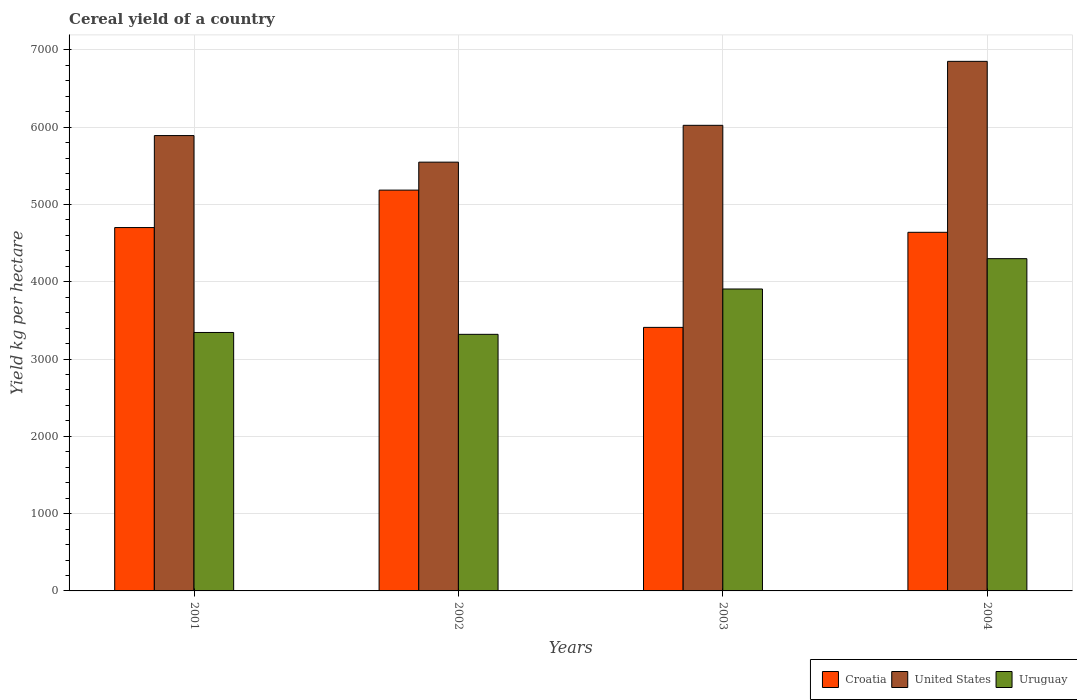How many different coloured bars are there?
Your response must be concise. 3. How many groups of bars are there?
Your answer should be compact. 4. How many bars are there on the 3rd tick from the right?
Keep it short and to the point. 3. What is the label of the 3rd group of bars from the left?
Make the answer very short. 2003. In how many cases, is the number of bars for a given year not equal to the number of legend labels?
Keep it short and to the point. 0. What is the total cereal yield in United States in 2004?
Make the answer very short. 6851.66. Across all years, what is the maximum total cereal yield in United States?
Your answer should be very brief. 6851.66. Across all years, what is the minimum total cereal yield in Croatia?
Provide a succinct answer. 3409.78. What is the total total cereal yield in Uruguay in the graph?
Give a very brief answer. 1.49e+04. What is the difference between the total cereal yield in Croatia in 2002 and that in 2003?
Your answer should be very brief. 1775.9. What is the difference between the total cereal yield in Croatia in 2001 and the total cereal yield in Uruguay in 2004?
Keep it short and to the point. 402.5. What is the average total cereal yield in United States per year?
Provide a succinct answer. 6078.67. In the year 2001, what is the difference between the total cereal yield in Croatia and total cereal yield in United States?
Offer a terse response. -1190.12. In how many years, is the total cereal yield in United States greater than 4200 kg per hectare?
Keep it short and to the point. 4. What is the ratio of the total cereal yield in United States in 2001 to that in 2003?
Provide a succinct answer. 0.98. What is the difference between the highest and the second highest total cereal yield in Uruguay?
Make the answer very short. 392.42. What is the difference between the highest and the lowest total cereal yield in United States?
Offer a terse response. 1304.18. In how many years, is the total cereal yield in Uruguay greater than the average total cereal yield in Uruguay taken over all years?
Your response must be concise. 2. Is the sum of the total cereal yield in Uruguay in 2001 and 2002 greater than the maximum total cereal yield in Croatia across all years?
Provide a short and direct response. Yes. What does the 1st bar from the left in 2003 represents?
Offer a terse response. Croatia. What does the 1st bar from the right in 2004 represents?
Your answer should be compact. Uruguay. Is it the case that in every year, the sum of the total cereal yield in Uruguay and total cereal yield in United States is greater than the total cereal yield in Croatia?
Ensure brevity in your answer.  Yes. How many bars are there?
Offer a very short reply. 12. Are all the bars in the graph horizontal?
Your answer should be very brief. No. What is the difference between two consecutive major ticks on the Y-axis?
Offer a terse response. 1000. Are the values on the major ticks of Y-axis written in scientific E-notation?
Keep it short and to the point. No. Where does the legend appear in the graph?
Offer a very short reply. Bottom right. What is the title of the graph?
Offer a very short reply. Cereal yield of a country. Does "Greenland" appear as one of the legend labels in the graph?
Keep it short and to the point. No. What is the label or title of the Y-axis?
Offer a very short reply. Yield kg per hectare. What is the Yield kg per hectare in Croatia in 2001?
Keep it short and to the point. 4701.4. What is the Yield kg per hectare in United States in 2001?
Your answer should be compact. 5891.52. What is the Yield kg per hectare in Uruguay in 2001?
Your answer should be compact. 3343.86. What is the Yield kg per hectare of Croatia in 2002?
Keep it short and to the point. 5185.67. What is the Yield kg per hectare in United States in 2002?
Provide a short and direct response. 5547.48. What is the Yield kg per hectare in Uruguay in 2002?
Your answer should be compact. 3319.71. What is the Yield kg per hectare in Croatia in 2003?
Keep it short and to the point. 3409.78. What is the Yield kg per hectare in United States in 2003?
Your response must be concise. 6024.03. What is the Yield kg per hectare of Uruguay in 2003?
Keep it short and to the point. 3906.49. What is the Yield kg per hectare in Croatia in 2004?
Provide a short and direct response. 4639.93. What is the Yield kg per hectare of United States in 2004?
Your answer should be compact. 6851.66. What is the Yield kg per hectare in Uruguay in 2004?
Your answer should be compact. 4298.91. Across all years, what is the maximum Yield kg per hectare in Croatia?
Your answer should be very brief. 5185.67. Across all years, what is the maximum Yield kg per hectare of United States?
Ensure brevity in your answer.  6851.66. Across all years, what is the maximum Yield kg per hectare of Uruguay?
Provide a succinct answer. 4298.91. Across all years, what is the minimum Yield kg per hectare of Croatia?
Provide a short and direct response. 3409.78. Across all years, what is the minimum Yield kg per hectare of United States?
Offer a very short reply. 5547.48. Across all years, what is the minimum Yield kg per hectare in Uruguay?
Give a very brief answer. 3319.71. What is the total Yield kg per hectare of Croatia in the graph?
Give a very brief answer. 1.79e+04. What is the total Yield kg per hectare of United States in the graph?
Give a very brief answer. 2.43e+04. What is the total Yield kg per hectare of Uruguay in the graph?
Offer a terse response. 1.49e+04. What is the difference between the Yield kg per hectare in Croatia in 2001 and that in 2002?
Provide a short and direct response. -484.27. What is the difference between the Yield kg per hectare in United States in 2001 and that in 2002?
Ensure brevity in your answer.  344.05. What is the difference between the Yield kg per hectare in Uruguay in 2001 and that in 2002?
Provide a short and direct response. 24.16. What is the difference between the Yield kg per hectare of Croatia in 2001 and that in 2003?
Provide a short and direct response. 1291.63. What is the difference between the Yield kg per hectare in United States in 2001 and that in 2003?
Keep it short and to the point. -132.51. What is the difference between the Yield kg per hectare of Uruguay in 2001 and that in 2003?
Your response must be concise. -562.62. What is the difference between the Yield kg per hectare of Croatia in 2001 and that in 2004?
Keep it short and to the point. 61.48. What is the difference between the Yield kg per hectare in United States in 2001 and that in 2004?
Ensure brevity in your answer.  -960.14. What is the difference between the Yield kg per hectare in Uruguay in 2001 and that in 2004?
Offer a very short reply. -955.04. What is the difference between the Yield kg per hectare of Croatia in 2002 and that in 2003?
Your answer should be compact. 1775.9. What is the difference between the Yield kg per hectare of United States in 2002 and that in 2003?
Give a very brief answer. -476.56. What is the difference between the Yield kg per hectare of Uruguay in 2002 and that in 2003?
Keep it short and to the point. -586.78. What is the difference between the Yield kg per hectare in Croatia in 2002 and that in 2004?
Make the answer very short. 545.75. What is the difference between the Yield kg per hectare of United States in 2002 and that in 2004?
Your answer should be very brief. -1304.18. What is the difference between the Yield kg per hectare in Uruguay in 2002 and that in 2004?
Offer a very short reply. -979.2. What is the difference between the Yield kg per hectare in Croatia in 2003 and that in 2004?
Your answer should be very brief. -1230.15. What is the difference between the Yield kg per hectare of United States in 2003 and that in 2004?
Your answer should be compact. -827.63. What is the difference between the Yield kg per hectare of Uruguay in 2003 and that in 2004?
Your answer should be compact. -392.42. What is the difference between the Yield kg per hectare in Croatia in 2001 and the Yield kg per hectare in United States in 2002?
Ensure brevity in your answer.  -846.07. What is the difference between the Yield kg per hectare of Croatia in 2001 and the Yield kg per hectare of Uruguay in 2002?
Provide a short and direct response. 1381.69. What is the difference between the Yield kg per hectare in United States in 2001 and the Yield kg per hectare in Uruguay in 2002?
Your response must be concise. 2571.81. What is the difference between the Yield kg per hectare of Croatia in 2001 and the Yield kg per hectare of United States in 2003?
Provide a succinct answer. -1322.63. What is the difference between the Yield kg per hectare of Croatia in 2001 and the Yield kg per hectare of Uruguay in 2003?
Offer a very short reply. 794.91. What is the difference between the Yield kg per hectare in United States in 2001 and the Yield kg per hectare in Uruguay in 2003?
Provide a short and direct response. 1985.03. What is the difference between the Yield kg per hectare of Croatia in 2001 and the Yield kg per hectare of United States in 2004?
Offer a very short reply. -2150.26. What is the difference between the Yield kg per hectare in Croatia in 2001 and the Yield kg per hectare in Uruguay in 2004?
Offer a very short reply. 402.5. What is the difference between the Yield kg per hectare in United States in 2001 and the Yield kg per hectare in Uruguay in 2004?
Provide a short and direct response. 1592.61. What is the difference between the Yield kg per hectare of Croatia in 2002 and the Yield kg per hectare of United States in 2003?
Make the answer very short. -838.36. What is the difference between the Yield kg per hectare of Croatia in 2002 and the Yield kg per hectare of Uruguay in 2003?
Offer a terse response. 1279.18. What is the difference between the Yield kg per hectare in United States in 2002 and the Yield kg per hectare in Uruguay in 2003?
Provide a short and direct response. 1640.98. What is the difference between the Yield kg per hectare of Croatia in 2002 and the Yield kg per hectare of United States in 2004?
Your answer should be compact. -1665.99. What is the difference between the Yield kg per hectare in Croatia in 2002 and the Yield kg per hectare in Uruguay in 2004?
Provide a short and direct response. 886.77. What is the difference between the Yield kg per hectare in United States in 2002 and the Yield kg per hectare in Uruguay in 2004?
Provide a succinct answer. 1248.57. What is the difference between the Yield kg per hectare in Croatia in 2003 and the Yield kg per hectare in United States in 2004?
Your response must be concise. -3441.88. What is the difference between the Yield kg per hectare of Croatia in 2003 and the Yield kg per hectare of Uruguay in 2004?
Your response must be concise. -889.13. What is the difference between the Yield kg per hectare in United States in 2003 and the Yield kg per hectare in Uruguay in 2004?
Your answer should be very brief. 1725.13. What is the average Yield kg per hectare in Croatia per year?
Give a very brief answer. 4484.2. What is the average Yield kg per hectare in United States per year?
Provide a succinct answer. 6078.67. What is the average Yield kg per hectare in Uruguay per year?
Provide a succinct answer. 3717.24. In the year 2001, what is the difference between the Yield kg per hectare of Croatia and Yield kg per hectare of United States?
Keep it short and to the point. -1190.12. In the year 2001, what is the difference between the Yield kg per hectare in Croatia and Yield kg per hectare in Uruguay?
Provide a succinct answer. 1357.54. In the year 2001, what is the difference between the Yield kg per hectare of United States and Yield kg per hectare of Uruguay?
Give a very brief answer. 2547.66. In the year 2002, what is the difference between the Yield kg per hectare in Croatia and Yield kg per hectare in United States?
Your response must be concise. -361.8. In the year 2002, what is the difference between the Yield kg per hectare in Croatia and Yield kg per hectare in Uruguay?
Your response must be concise. 1865.96. In the year 2002, what is the difference between the Yield kg per hectare in United States and Yield kg per hectare in Uruguay?
Provide a short and direct response. 2227.77. In the year 2003, what is the difference between the Yield kg per hectare of Croatia and Yield kg per hectare of United States?
Your response must be concise. -2614.26. In the year 2003, what is the difference between the Yield kg per hectare of Croatia and Yield kg per hectare of Uruguay?
Keep it short and to the point. -496.71. In the year 2003, what is the difference between the Yield kg per hectare of United States and Yield kg per hectare of Uruguay?
Provide a succinct answer. 2117.54. In the year 2004, what is the difference between the Yield kg per hectare in Croatia and Yield kg per hectare in United States?
Ensure brevity in your answer.  -2211.73. In the year 2004, what is the difference between the Yield kg per hectare in Croatia and Yield kg per hectare in Uruguay?
Give a very brief answer. 341.02. In the year 2004, what is the difference between the Yield kg per hectare in United States and Yield kg per hectare in Uruguay?
Your answer should be very brief. 2552.75. What is the ratio of the Yield kg per hectare of Croatia in 2001 to that in 2002?
Offer a very short reply. 0.91. What is the ratio of the Yield kg per hectare of United States in 2001 to that in 2002?
Provide a succinct answer. 1.06. What is the ratio of the Yield kg per hectare in Uruguay in 2001 to that in 2002?
Provide a succinct answer. 1.01. What is the ratio of the Yield kg per hectare in Croatia in 2001 to that in 2003?
Make the answer very short. 1.38. What is the ratio of the Yield kg per hectare of Uruguay in 2001 to that in 2003?
Offer a terse response. 0.86. What is the ratio of the Yield kg per hectare in Croatia in 2001 to that in 2004?
Provide a succinct answer. 1.01. What is the ratio of the Yield kg per hectare of United States in 2001 to that in 2004?
Give a very brief answer. 0.86. What is the ratio of the Yield kg per hectare of Uruguay in 2001 to that in 2004?
Offer a very short reply. 0.78. What is the ratio of the Yield kg per hectare of Croatia in 2002 to that in 2003?
Your answer should be compact. 1.52. What is the ratio of the Yield kg per hectare in United States in 2002 to that in 2003?
Make the answer very short. 0.92. What is the ratio of the Yield kg per hectare of Uruguay in 2002 to that in 2003?
Offer a very short reply. 0.85. What is the ratio of the Yield kg per hectare in Croatia in 2002 to that in 2004?
Provide a succinct answer. 1.12. What is the ratio of the Yield kg per hectare of United States in 2002 to that in 2004?
Offer a very short reply. 0.81. What is the ratio of the Yield kg per hectare in Uruguay in 2002 to that in 2004?
Make the answer very short. 0.77. What is the ratio of the Yield kg per hectare of Croatia in 2003 to that in 2004?
Provide a succinct answer. 0.73. What is the ratio of the Yield kg per hectare in United States in 2003 to that in 2004?
Keep it short and to the point. 0.88. What is the ratio of the Yield kg per hectare in Uruguay in 2003 to that in 2004?
Provide a short and direct response. 0.91. What is the difference between the highest and the second highest Yield kg per hectare in Croatia?
Your answer should be compact. 484.27. What is the difference between the highest and the second highest Yield kg per hectare in United States?
Ensure brevity in your answer.  827.63. What is the difference between the highest and the second highest Yield kg per hectare in Uruguay?
Make the answer very short. 392.42. What is the difference between the highest and the lowest Yield kg per hectare of Croatia?
Your answer should be very brief. 1775.9. What is the difference between the highest and the lowest Yield kg per hectare of United States?
Keep it short and to the point. 1304.18. What is the difference between the highest and the lowest Yield kg per hectare of Uruguay?
Offer a terse response. 979.2. 